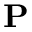<formula> <loc_0><loc_0><loc_500><loc_500>P</formula> 